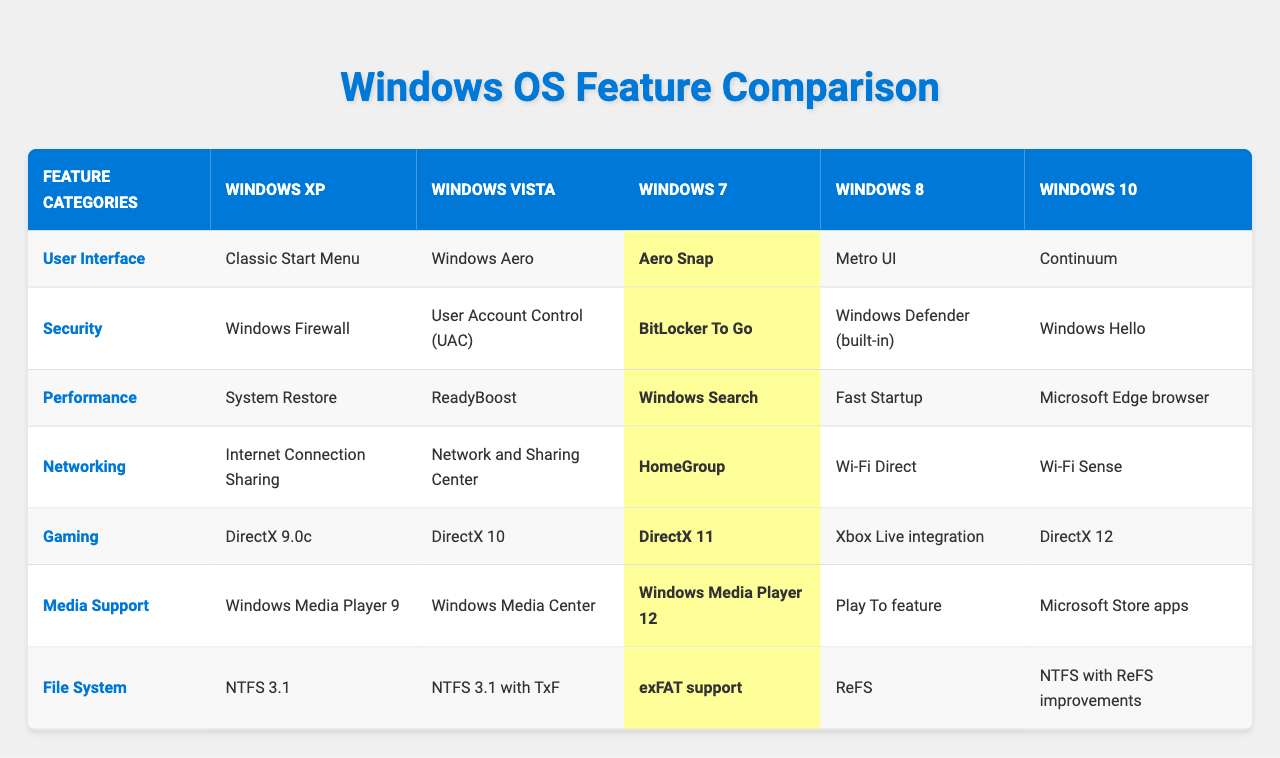What user interface feature was introduced in Windows 7? The table shows that Windows 7 introduced the "Aero Snap" feature in the User Interface category.
Answer: Aero Snap Which version of Windows first included a built-in antivirus feature? According to the table, Windows 8 introduced the built-in antivirus feature called "Windows Defender."
Answer: Yes In terms of gaming, how does DirectX 11 in Windows 7 compare to DirectX 12 in Windows 10? The table indicates that Windows 10 has DirectX 12, which is a newer version than DirectX 11 from Windows 7, therefore offering improved gaming features.
Answer: DirectX 12 is better Which file system supports improvements in NTFS in Windows 10? The table specifies that Windows 10 supports NTFS with ReFS improvements, while previous versions used regular NTFS.
Answer: ReFS improvements What is the main difference in the networking feature between Windows XP and Windows 8? In the table, Windows XP offers "Internet Connection Sharing" whereas Windows 8 provides "Wi-Fi Direct," indicating a shift to more modern networking standards.
Answer: Wi-Fi Direct is more advanced What was the key performance feature added in Windows Vista? The table shows that Windows Vista introduced "ReadyBoost" as a performance feature.
Answer: ReadyBoost Which Windows version has Media Center as a media support feature? The table indicates that "Windows Media Center" was included in Windows Vista under Media Support.
Answer: Windows Vista How many versions of Windows include DirectX support? By reviewing the gaming section of the table, we see that Windows XP, Vista, 7, 8, and 10 all have DirectX support, totaling 5 versions.
Answer: 5 What is the primary difference in security features from Windows XP to Windows 10? The security feature of Windows XP is "Windows Firewall," while Windows 10 includes "Windows Hello," which signifies a broader range of security mechanisms in modern systems.
Answer: Windows Hello is more advanced How does the performance improvement from Windows 8's Fast Startup compare to Windows XP's System Restore? Windows 8's "Fast Startup" feature is designed to enhance boot speed significantly compared to Windows XP's "System Restore," which primarily focuses on system recovery rather than startup speed.
Answer: Fast Startup is a boot speed improvement What user interface feature distinguishes Windows 10 from Windows 8? The table specifies that Windows 10 has "Continuum," while Windows 8 featured "Metro UI," indicating a shift towards a more adaptable interface in Windows 10.
Answer: Continuum distinguishes Windows 10 